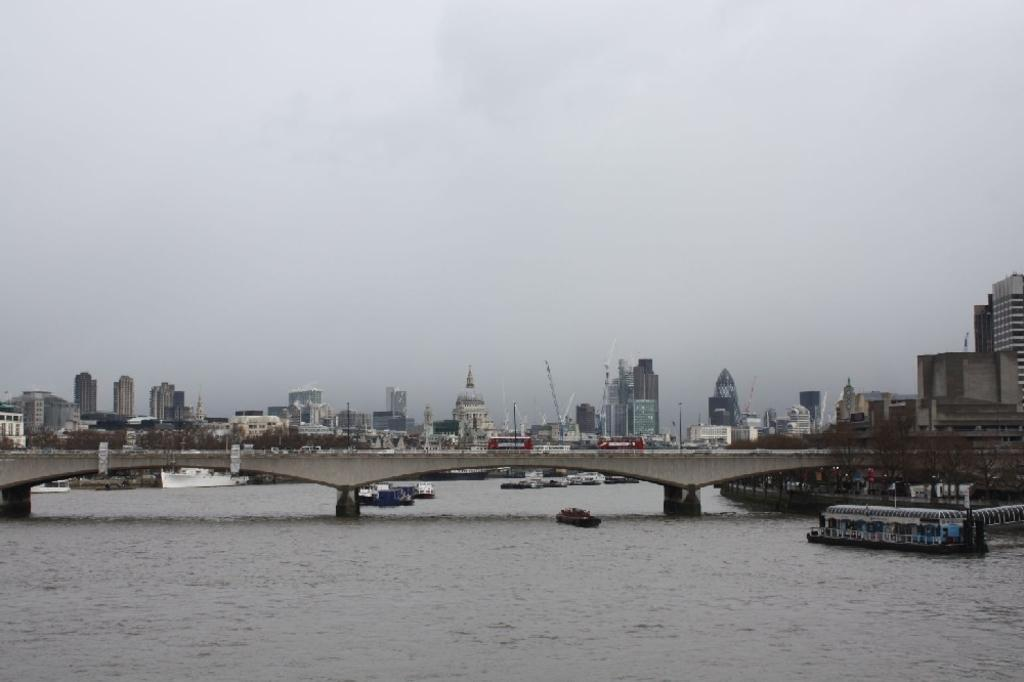What is the main subject in the center of the image? There is water in the center of the image. What is floating on the water? There are boats in the water. What structure can be seen in the image? There is a bridge in the image. What is on the bridge? Vehicles are present on the bridge. What can be seen in the background of the image? There is sky visible in the background of the image, with clouds present. What else is visible in the background? There are buildings in the background of the image. What type of furniture can be seen on the sidewalk in the image? There is no furniture or sidewalk present in the image; it features water, boats, a bridge, vehicles, sky, clouds, and buildings. 